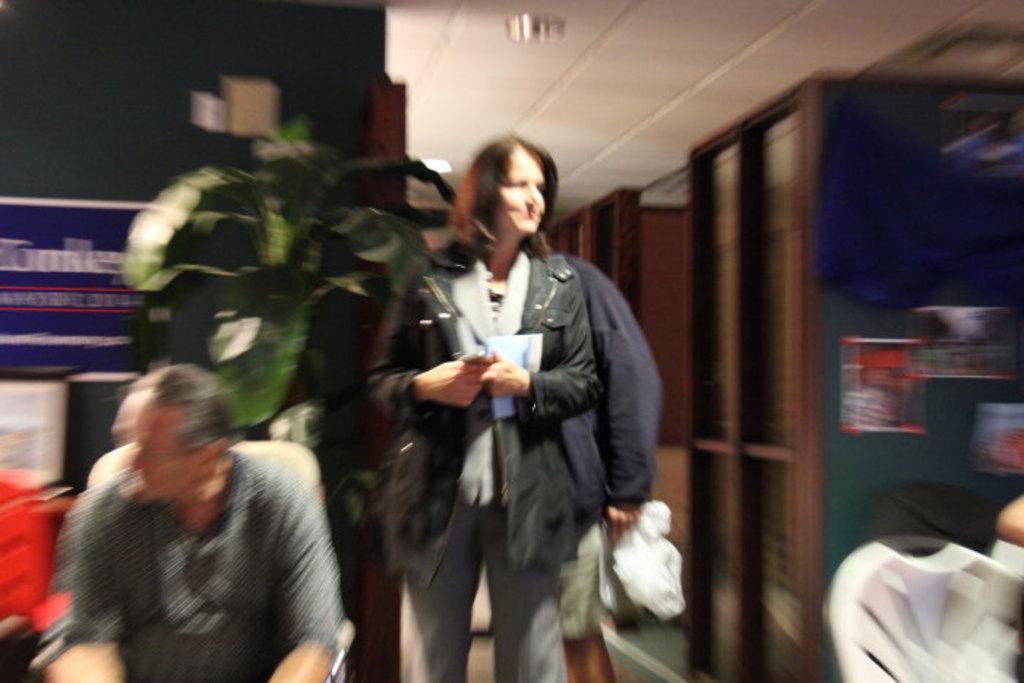How would you summarize this image in a sentence or two? In the image there is a woman in black jacket standing in the middle of the room with a man standing behind her and another man sitting beside her, in the back there is a plant in front of wall, on the right side there are chairs in front of the wooden lobby, there are lights over the ceiling. 